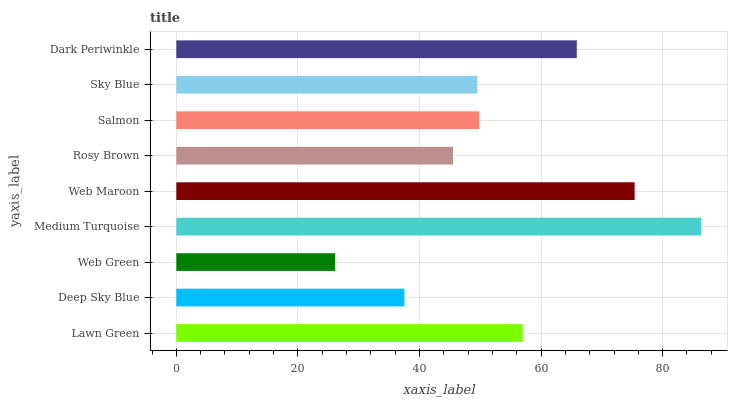Is Web Green the minimum?
Answer yes or no. Yes. Is Medium Turquoise the maximum?
Answer yes or no. Yes. Is Deep Sky Blue the minimum?
Answer yes or no. No. Is Deep Sky Blue the maximum?
Answer yes or no. No. Is Lawn Green greater than Deep Sky Blue?
Answer yes or no. Yes. Is Deep Sky Blue less than Lawn Green?
Answer yes or no. Yes. Is Deep Sky Blue greater than Lawn Green?
Answer yes or no. No. Is Lawn Green less than Deep Sky Blue?
Answer yes or no. No. Is Salmon the high median?
Answer yes or no. Yes. Is Salmon the low median?
Answer yes or no. Yes. Is Dark Periwinkle the high median?
Answer yes or no. No. Is Sky Blue the low median?
Answer yes or no. No. 